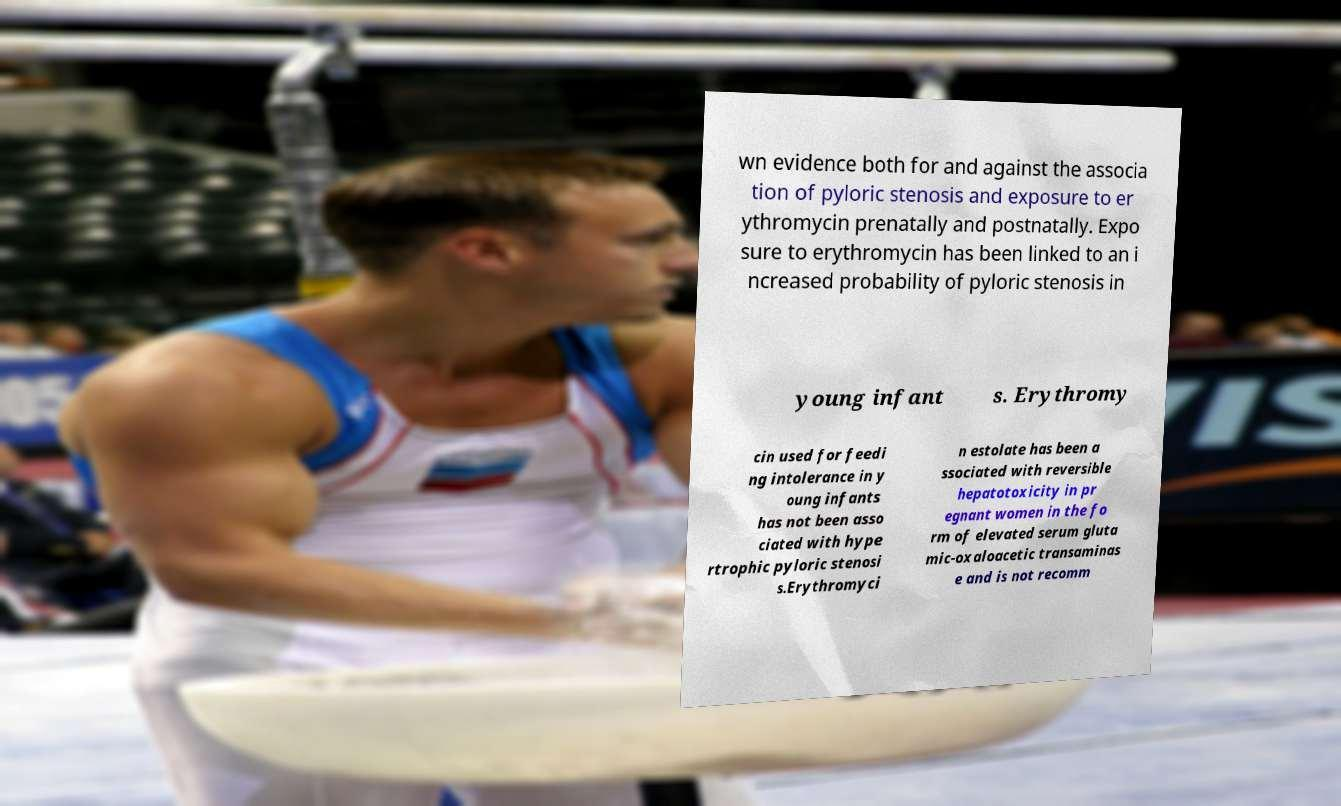Can you accurately transcribe the text from the provided image for me? wn evidence both for and against the associa tion of pyloric stenosis and exposure to er ythromycin prenatally and postnatally. Expo sure to erythromycin has been linked to an i ncreased probability of pyloric stenosis in young infant s. Erythromy cin used for feedi ng intolerance in y oung infants has not been asso ciated with hype rtrophic pyloric stenosi s.Erythromyci n estolate has been a ssociated with reversible hepatotoxicity in pr egnant women in the fo rm of elevated serum gluta mic-oxaloacetic transaminas e and is not recomm 